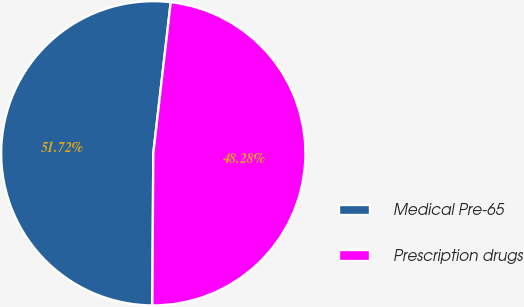<chart> <loc_0><loc_0><loc_500><loc_500><pie_chart><fcel>Medical Pre-65<fcel>Prescription drugs<nl><fcel>51.72%<fcel>48.28%<nl></chart> 